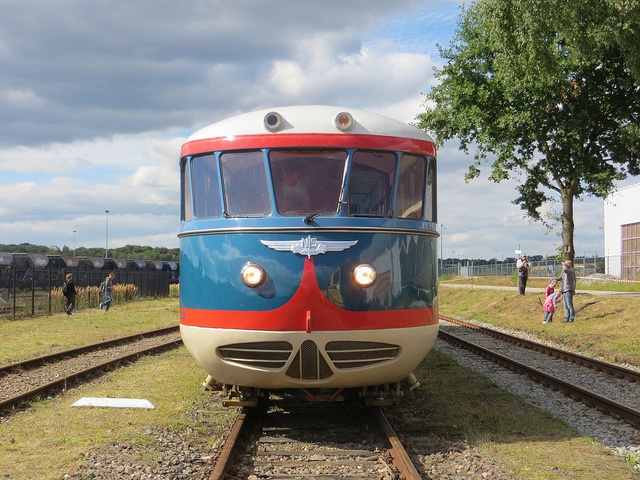Describe the objects in this image and their specific colors. I can see train in darkgray, gray, black, lightgray, and brown tones, people in darkgray, gray, black, and tan tones, people in darkgray, black, gray, and ivory tones, people in darkgray, black, and gray tones, and people in darkgray, lightpink, pink, and gray tones in this image. 